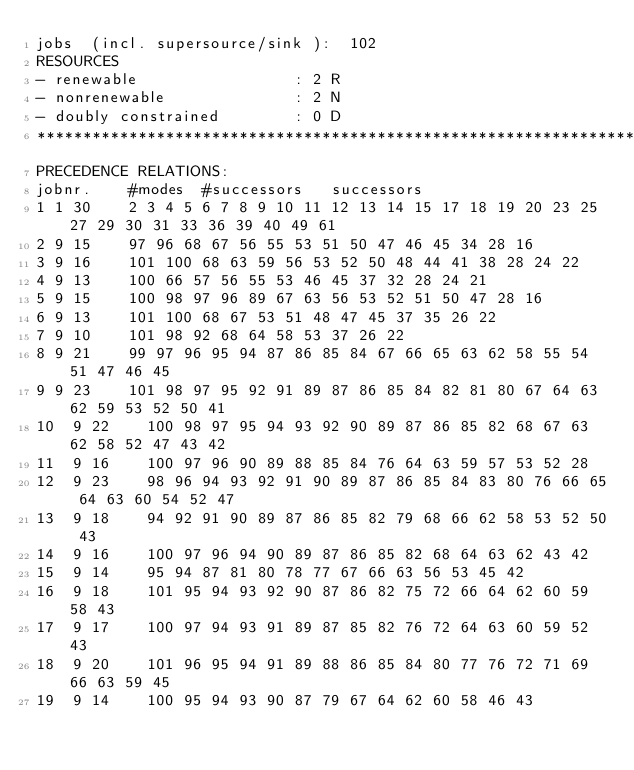Convert code to text. <code><loc_0><loc_0><loc_500><loc_500><_ObjectiveC_>jobs  (incl. supersource/sink ):	102
RESOURCES
- renewable                 : 2 R
- nonrenewable              : 2 N
- doubly constrained        : 0 D
************************************************************************
PRECEDENCE RELATIONS:
jobnr.    #modes  #successors   successors
1	1	30		2 3 4 5 6 7 8 9 10 11 12 13 14 15 17 18 19 20 23 25 27 29 30 31 33 36 39 40 49 61 
2	9	15		97 96 68 67 56 55 53 51 50 47 46 45 34 28 16 
3	9	16		101 100 68 63 59 56 53 52 50 48 44 41 38 28 24 22 
4	9	13		100 66 57 56 55 53 46 45 37 32 28 24 21 
5	9	15		100 98 97 96 89 67 63 56 53 52 51 50 47 28 16 
6	9	13		101 100 68 67 53 51 48 47 45 37 35 26 22 
7	9	10		101 98 92 68 64 58 53 37 26 22 
8	9	21		99 97 96 95 94 87 86 85 84 67 66 65 63 62 58 55 54 51 47 46 45 
9	9	23		101 98 97 95 92 91 89 87 86 85 84 82 81 80 67 64 63 62 59 53 52 50 41 
10	9	22		100 98 97 95 94 93 92 90 89 87 86 85 82 68 67 63 62 58 52 47 43 42 
11	9	16		100 97 96 90 89 88 85 84 76 64 63 59 57 53 52 28 
12	9	23		98 96 94 93 92 91 90 89 87 86 85 84 83 80 76 66 65 64 63 60 54 52 47 
13	9	18		94 92 91 90 89 87 86 85 82 79 68 66 62 58 53 52 50 43 
14	9	16		100 97 96 94 90 89 87 86 85 82 68 64 63 62 43 42 
15	9	14		95 94 87 81 80 78 77 67 66 63 56 53 45 42 
16	9	18		101 95 94 93 92 90 87 86 82 75 72 66 64 62 60 59 58 43 
17	9	17		100 97 94 93 91 89 87 85 82 76 72 64 63 60 59 52 43 
18	9	20		101 96 95 94 91 89 88 86 85 84 80 77 76 72 71 69 66 63 59 45 
19	9	14		100 95 94 93 90 87 79 67 64 62 60 58 46 43 </code> 